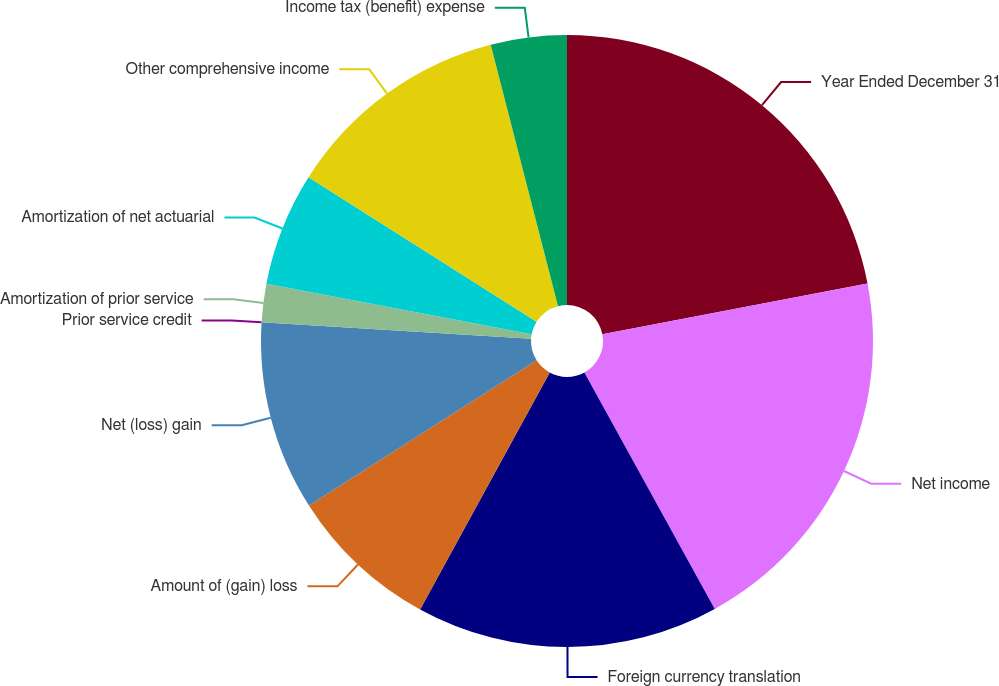Convert chart to OTSL. <chart><loc_0><loc_0><loc_500><loc_500><pie_chart><fcel>Year Ended December 31<fcel>Net income<fcel>Foreign currency translation<fcel>Amount of (gain) loss<fcel>Net (loss) gain<fcel>Prior service credit<fcel>Amortization of prior service<fcel>Amortization of net actuarial<fcel>Other comprehensive income<fcel>Income tax (benefit) expense<nl><fcel>21.99%<fcel>19.99%<fcel>15.99%<fcel>8.0%<fcel>10.0%<fcel>0.01%<fcel>2.01%<fcel>6.0%<fcel>12.0%<fcel>4.01%<nl></chart> 